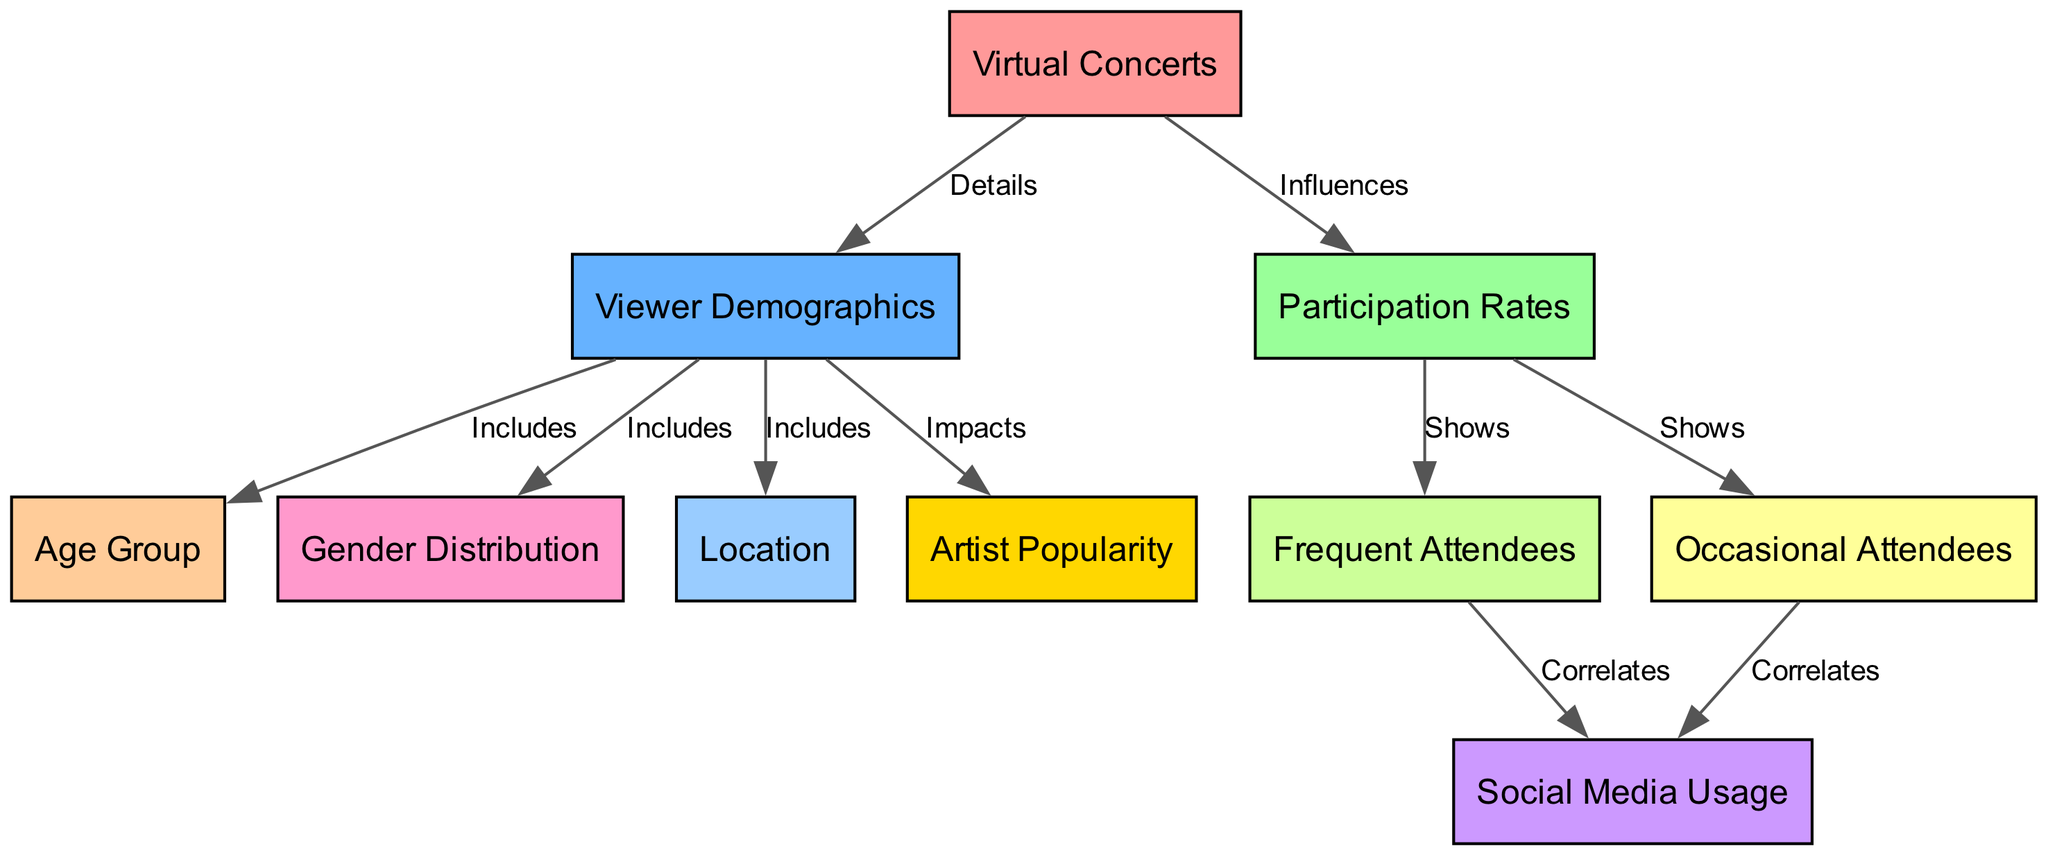What is the main topic of the diagram? The main topic of the diagram is identified by the first node, which states "Virtual Concerts." This node is the starting point that connects to other aspects related to viewer demographics and participation rates.
Answer: Virtual Concerts How many viewer demographics are included in the diagram? The viewer demographics node connects to three specific categories: Age Group, Gender Distribution, and Location. By counting these connections, we determine there are three viewer demographics included.
Answer: 3 What influences participation rates according to the diagram? The diagram indicates that "Virtual Concerts" influence "Participation Rates" through the relationship outlined with an edge labeled "Influences." This establishes the fundamental link that participation rates are affected by virtual concert attendance.
Answer: Virtual Concerts What do frequent attendees correlate with? The diagram shows that "Frequent Attendees" correlates with "Social Media Usage." This connection reveals the relationship that those who frequently attend virtual concerts also tend to engage with social media platforms actively.
Answer: Social Media Usage How many edges are in the diagram? The diagram presents a total of ten edges connecting the various nodes. By tallying the connections established between the nodes, we find the total count of edges in the diagram.
Answer: 10 Which node impacts viewer demographics? The connection labeled "Impacts" extending from "Viewer Demographics" to "Artist Popularity" indicates that viewer demographics are affected by the popularity of the artists involved in the virtual concerts.
Answer: Artist Popularity What is represented under the age group in viewer demographics? The diagram includes one specific category "Age Group" under the "Viewer Demographics" node, indicating that age is a distinguishing characteristic among virtual concert attendees.
Answer: Age Group What do occasional attendees show in the diagram? The relationship shows that "Occasional Attendees" correlate with "Social Media Usage," denoting that individuals who attend virtual concerts occasionally also tend to use social media platforms.
Answer: Social Media Usage How are frequent attendees categorized in the context of participation rates? The diagram illustrates that "Frequent Attendees" is a category under "Participation Rates," signifying that this group is defined by high levels of engagement in virtual concerts.
Answer: Frequent Attendees 